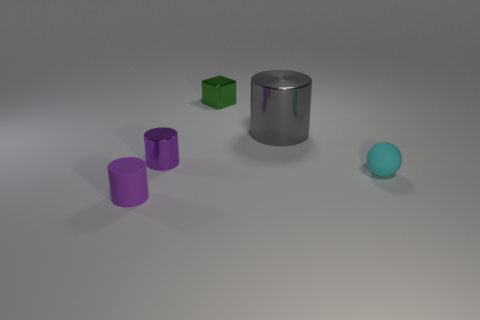There is a small purple thing that is in front of the small purple shiny object; does it have the same shape as the cyan thing?
Your response must be concise. No. There is a large shiny object that is the same shape as the tiny purple metal thing; what color is it?
Give a very brief answer. Gray. Is there anything else that is made of the same material as the cyan thing?
Your answer should be very brief. Yes. There is a purple matte thing that is the same shape as the large metal thing; what is its size?
Your answer should be very brief. Small. There is a small object that is to the right of the tiny purple shiny cylinder and in front of the tiny metallic cube; what material is it?
Your answer should be very brief. Rubber. Do the small object in front of the tiny cyan ball and the tiny rubber ball have the same color?
Make the answer very short. No. There is a tiny shiny block; is it the same color as the shiny thing to the right of the green thing?
Your response must be concise. No. There is a purple rubber cylinder; are there any tiny cyan matte spheres to the right of it?
Your response must be concise. Yes. Is the cyan object made of the same material as the large object?
Offer a very short reply. No. There is a cyan ball that is the same size as the purple rubber object; what is its material?
Provide a succinct answer. Rubber. 